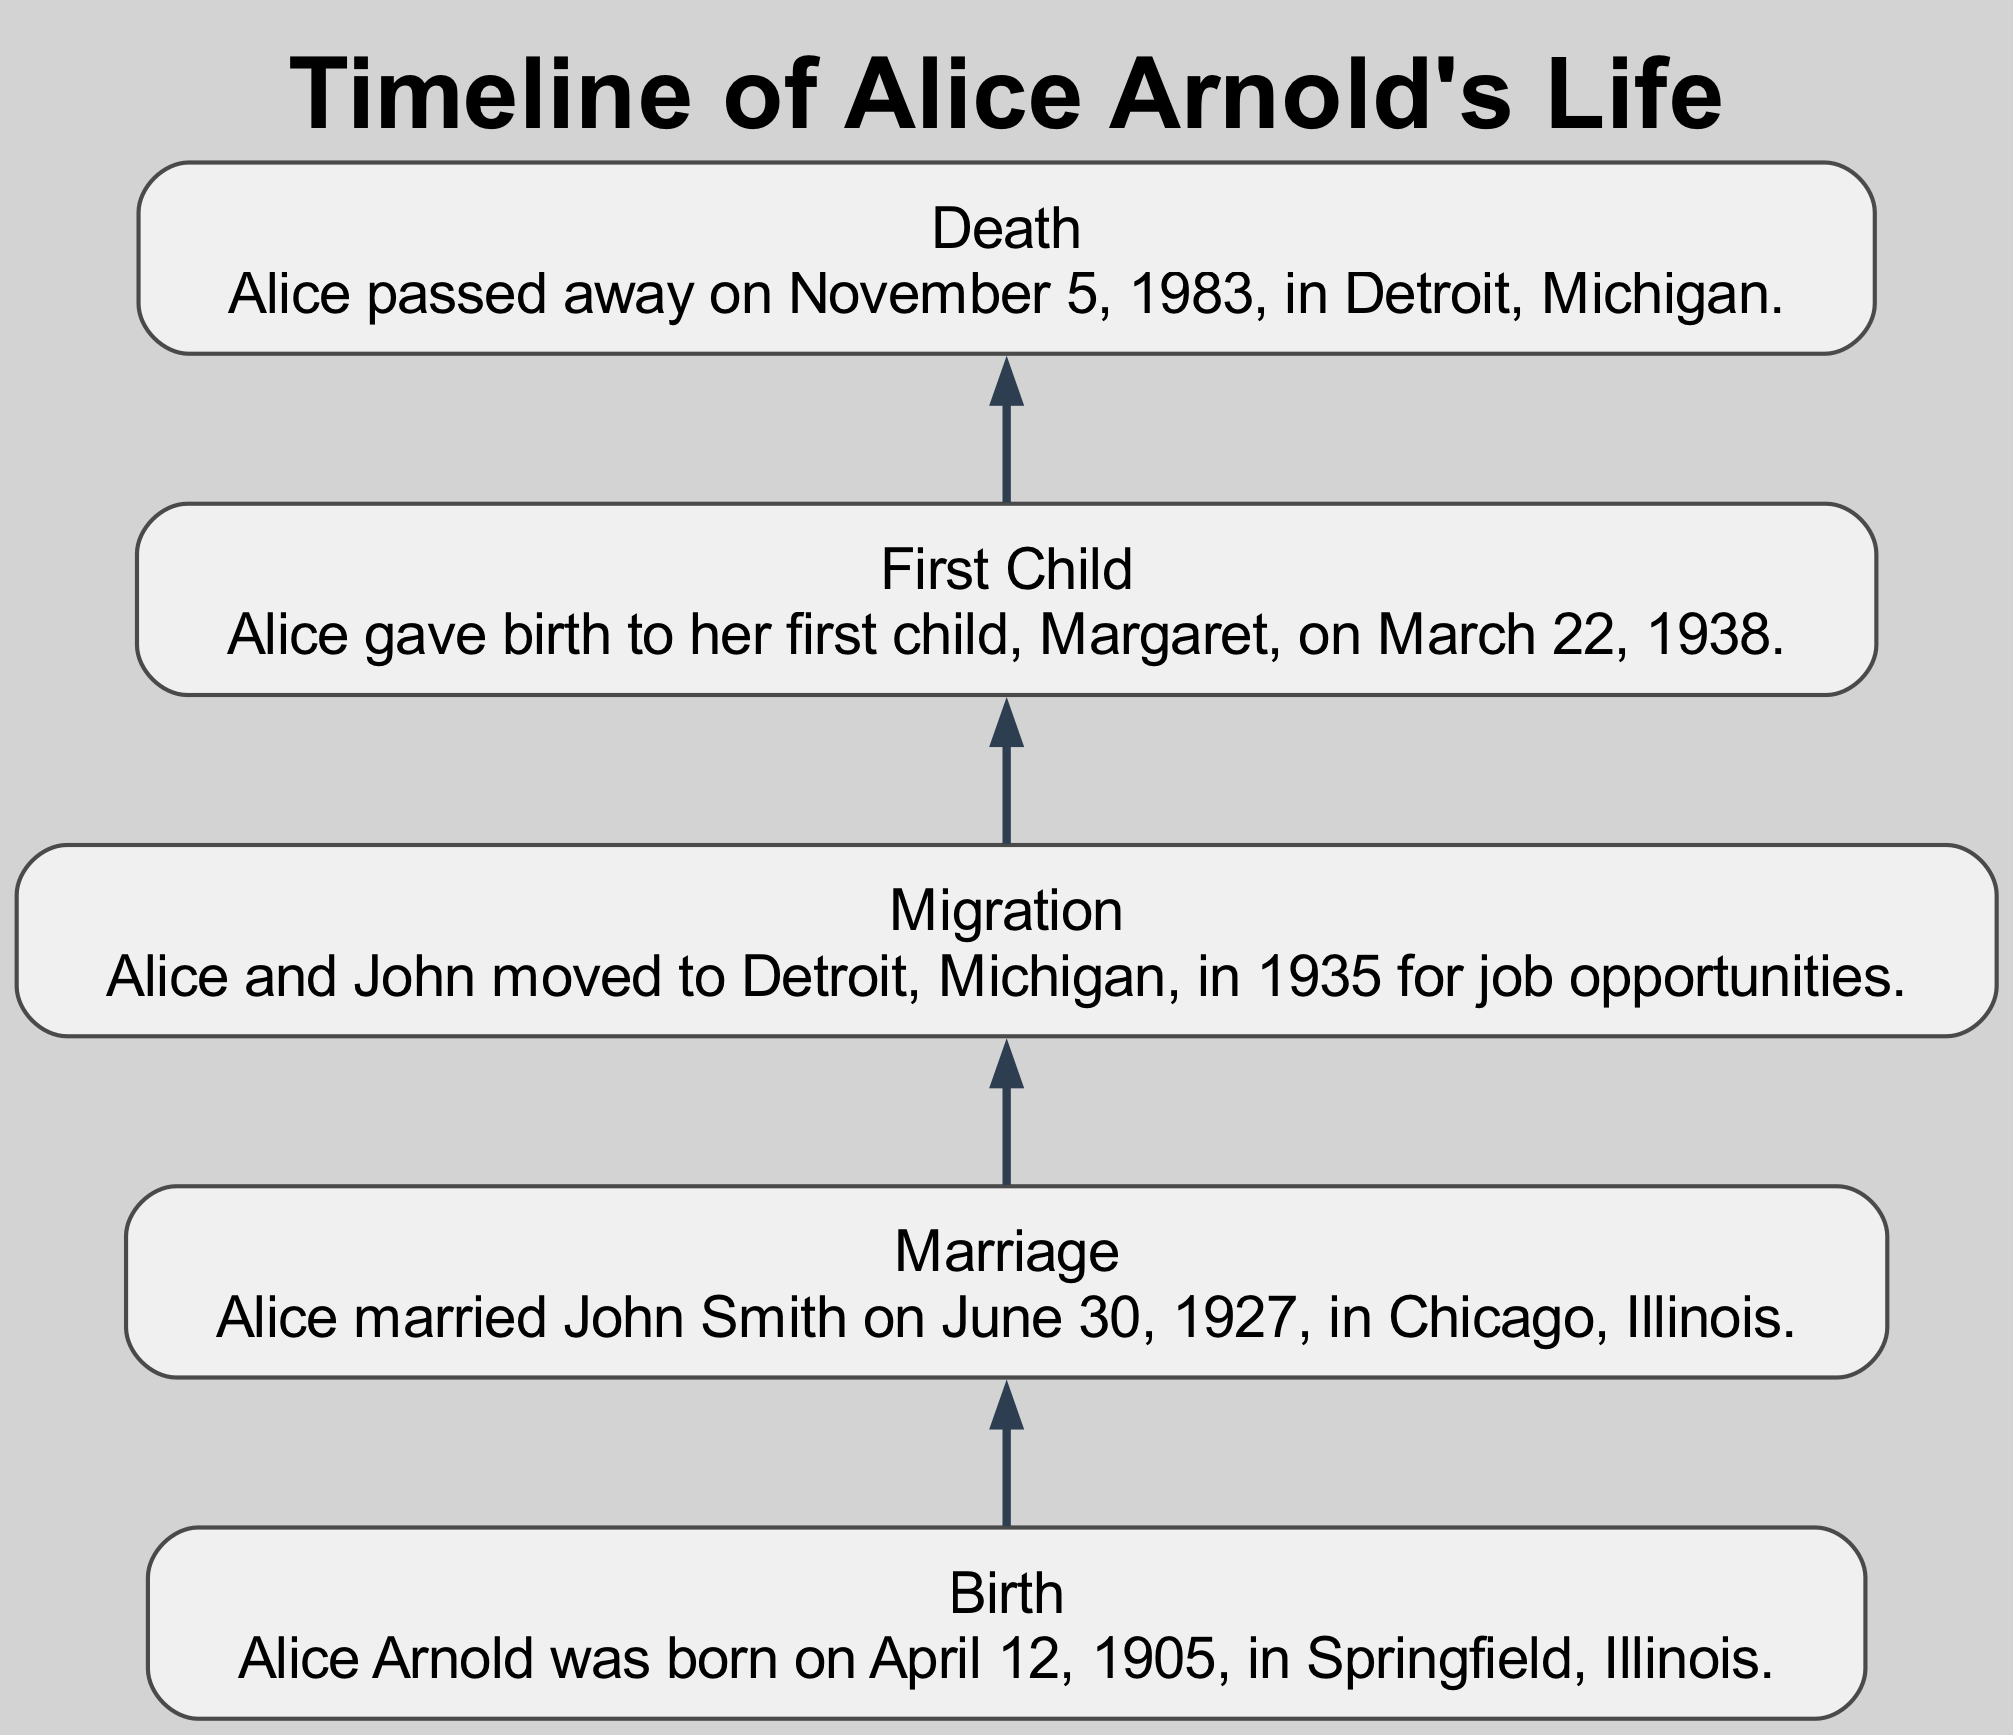What is the title of the first event in the diagram? The first event listed in the diagram is "Birth." It appears at the top of the flow chart, indicating it is the starting point of Alice Arnold's timeline.
Answer: Birth How many significant events are documented in Alice Arnold's life? There are five events documented in the diagram: Birth, Marriage, Migration, First Child, and Death. Each event is represented as a node in the flow chart.
Answer: 5 When did Alice get married? The Marriage event states that Alice married John Smith on June 30, 1927. This date is specifically mentioned in the description of the Marriage node in the diagram.
Answer: June 30, 1927 Where was Alice born? The Birth event indicates that Alice Arnold was born in Springfield, Illinois. The location is part of the description within the Birth node.
Answer: Springfield, Illinois What year did Alice and John migrate? The Migration event specifies that Alice and John moved to Detroit, Michigan, in 1935. This information is presented in the description of the Migration node.
Answer: 1935 What relationship exists between the Marriage and First Child events? The Marriage event occurs before the First Child event, indicating that Alice's marriage to John Smith happened prior to the birth of their first child, Margaret, in the flow of the diagram.
Answer: Sequential relationship Which event follows Alice's first child's birth? After Alice gave birth to her first child, the Death event follows in the flow chart, indicating the chronology of events in Alice's life as represented in the diagram.
Answer: Death What color are the nodes in the diagram? The nodes in the diagram are styled with a filled, rounded box shape that includes a light gray fill color. This is part of the custom node styling defined in the diagram's attributes.
Answer: Light gray What is the significance of the bottom-up layout of the diagram? The bottom-up layout emphasizes the chronological flow of events from Alice's early life starting with her birth at the top and moving downward through her life events. This arrangement helps to visualize the progression of time in her life's timeline.
Answer: Chronological flow 